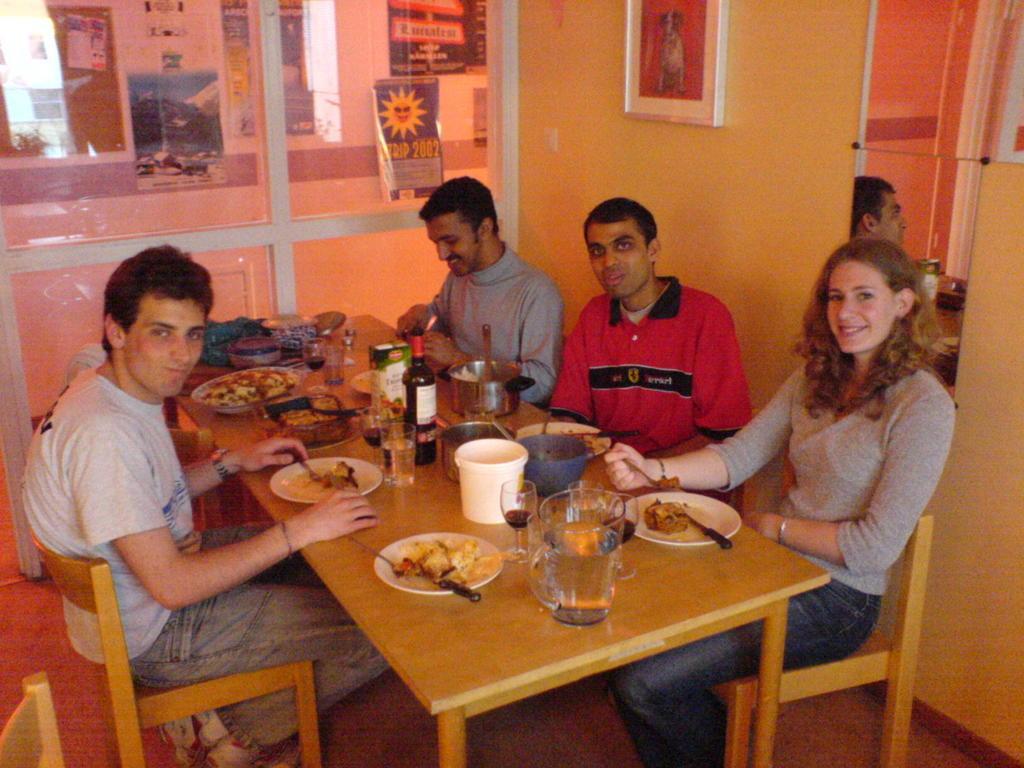Could you give a brief overview of what you see in this image? In this image there are group of persons who are sitting on a chairs having their drinks and food. 